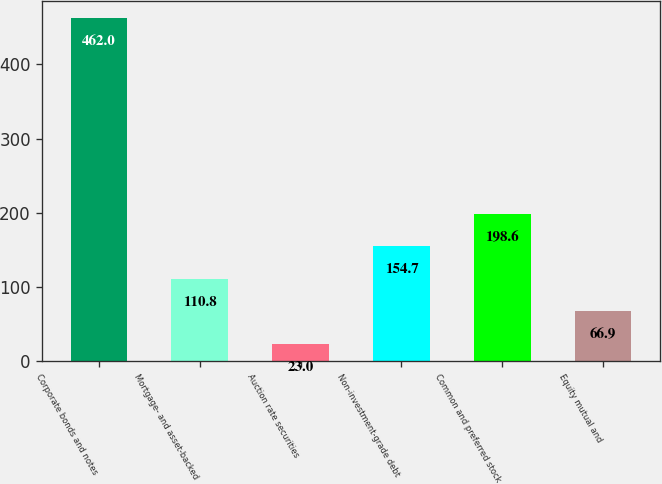<chart> <loc_0><loc_0><loc_500><loc_500><bar_chart><fcel>Corporate bonds and notes<fcel>Mortgage- and asset-backed<fcel>Auction rate securities<fcel>Non-investment-grade debt<fcel>Common and preferred stock<fcel>Equity mutual and<nl><fcel>462<fcel>110.8<fcel>23<fcel>154.7<fcel>198.6<fcel>66.9<nl></chart> 